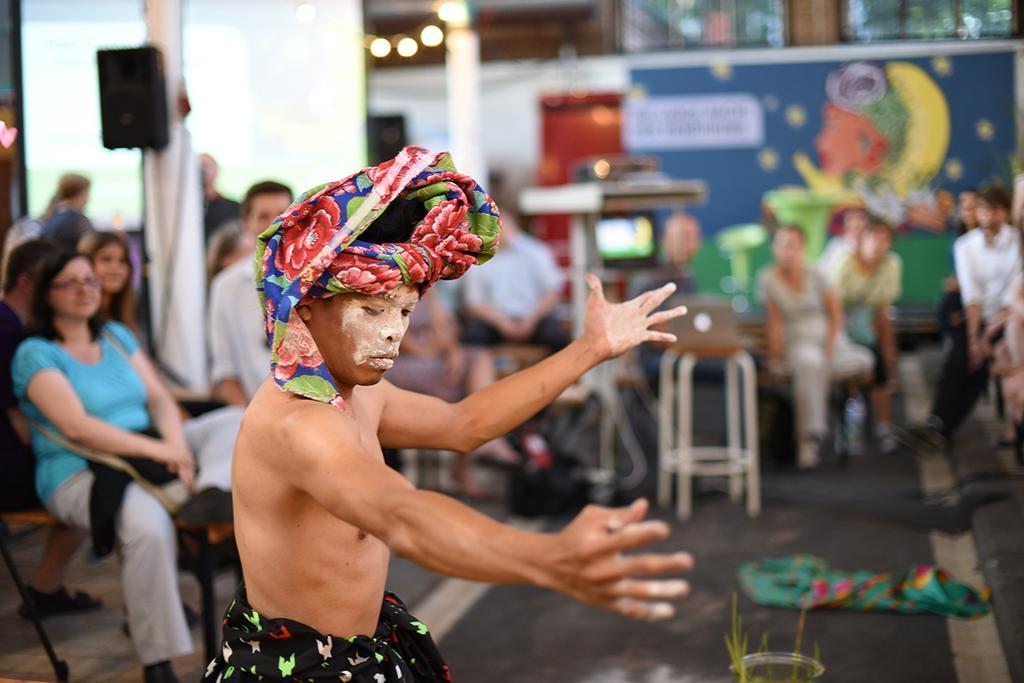How would you summarize this image in a sentence or two? There is a man in motion. We can see cloth and glass object. In the background it is blurry and we can see people sitting on chairs, speaker on pillar, painting on a wall and lights. 